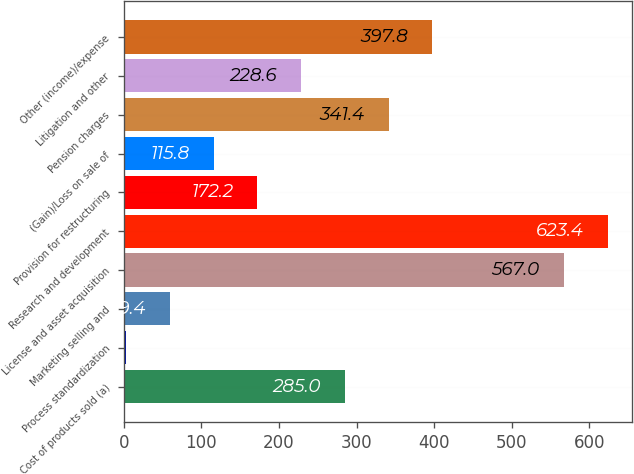Convert chart to OTSL. <chart><loc_0><loc_0><loc_500><loc_500><bar_chart><fcel>Cost of products sold (a)<fcel>Process standardization<fcel>Marketing selling and<fcel>License and asset acquisition<fcel>Research and development<fcel>Provision for restructuring<fcel>(Gain)/Loss on sale of<fcel>Pension charges<fcel>Litigation and other<fcel>Other (income)/expense<nl><fcel>285<fcel>3<fcel>59.4<fcel>567<fcel>623.4<fcel>172.2<fcel>115.8<fcel>341.4<fcel>228.6<fcel>397.8<nl></chart> 